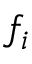Convert formula to latex. <formula><loc_0><loc_0><loc_500><loc_500>f _ { i }</formula> 